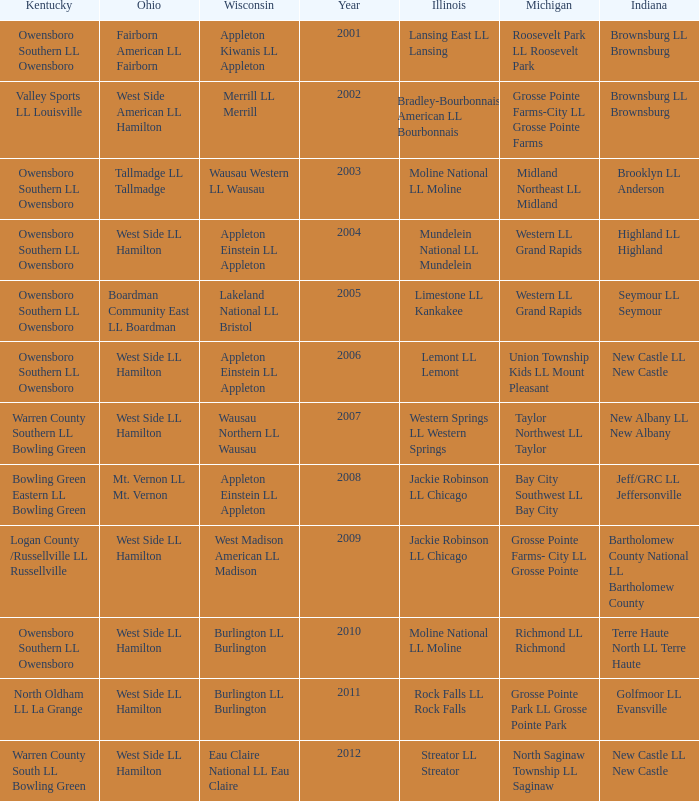What was the little league team from Kentucky when the little league team from Michigan was Grosse Pointe Farms-City LL Grosse Pointe Farms?  Valley Sports LL Louisville. 